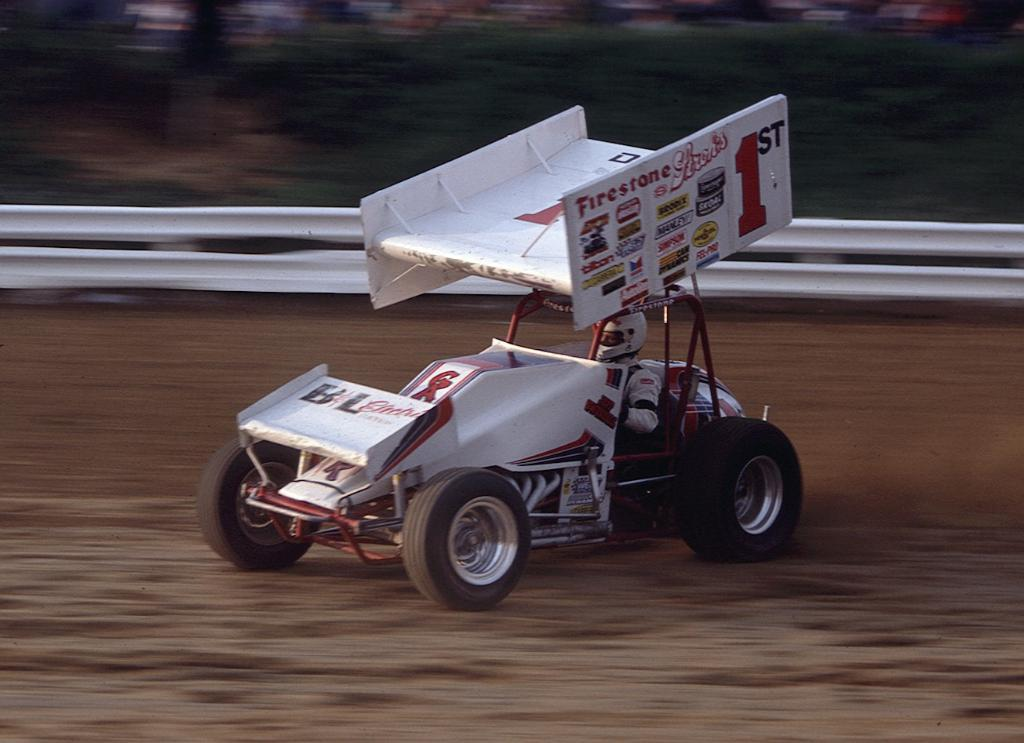Provide a one-sentence caption for the provided image. a small car racing that is sponsored by Firestone. 